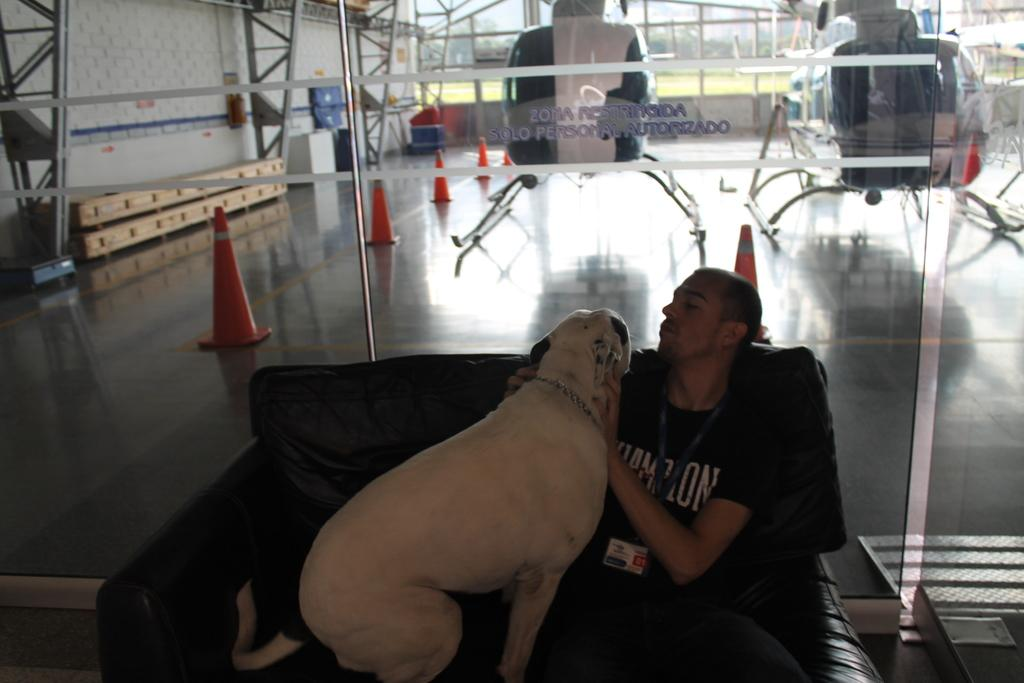What is the man in the image doing? The man is sitting on a chair in the image. What is the man holding in the image? The man is holding a dog in the image. What objects can be seen in the image besides the man and the dog? There are traffic cones in the image. What can be seen in the background of the image? There are helicopters visible in the background of the image. What type of stone is the dog biting in the image? There is no stone present in the image, nor is the dog biting anything. 